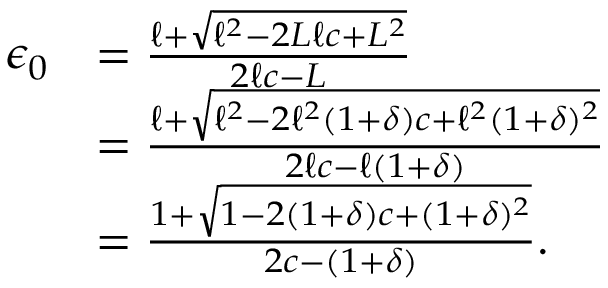<formula> <loc_0><loc_0><loc_500><loc_500>\begin{array} { r l } { \epsilon _ { 0 } } & { = \frac { \ell + \sqrt { \ell ^ { 2 } - 2 L \ell c + L ^ { 2 } } } { 2 \ell c - L } } \\ & { = \frac { \ell + \sqrt { \ell ^ { 2 } - 2 \ell ^ { 2 } ( 1 + \delta ) c + \ell ^ { 2 } ( 1 + \delta ) ^ { 2 } } } { 2 \ell c - \ell ( 1 + \delta ) } } \\ & { = \frac { 1 + \sqrt { 1 - 2 ( 1 + \delta ) c + ( 1 + \delta ) ^ { 2 } } } { 2 c - ( 1 + \delta ) } . } \end{array}</formula> 